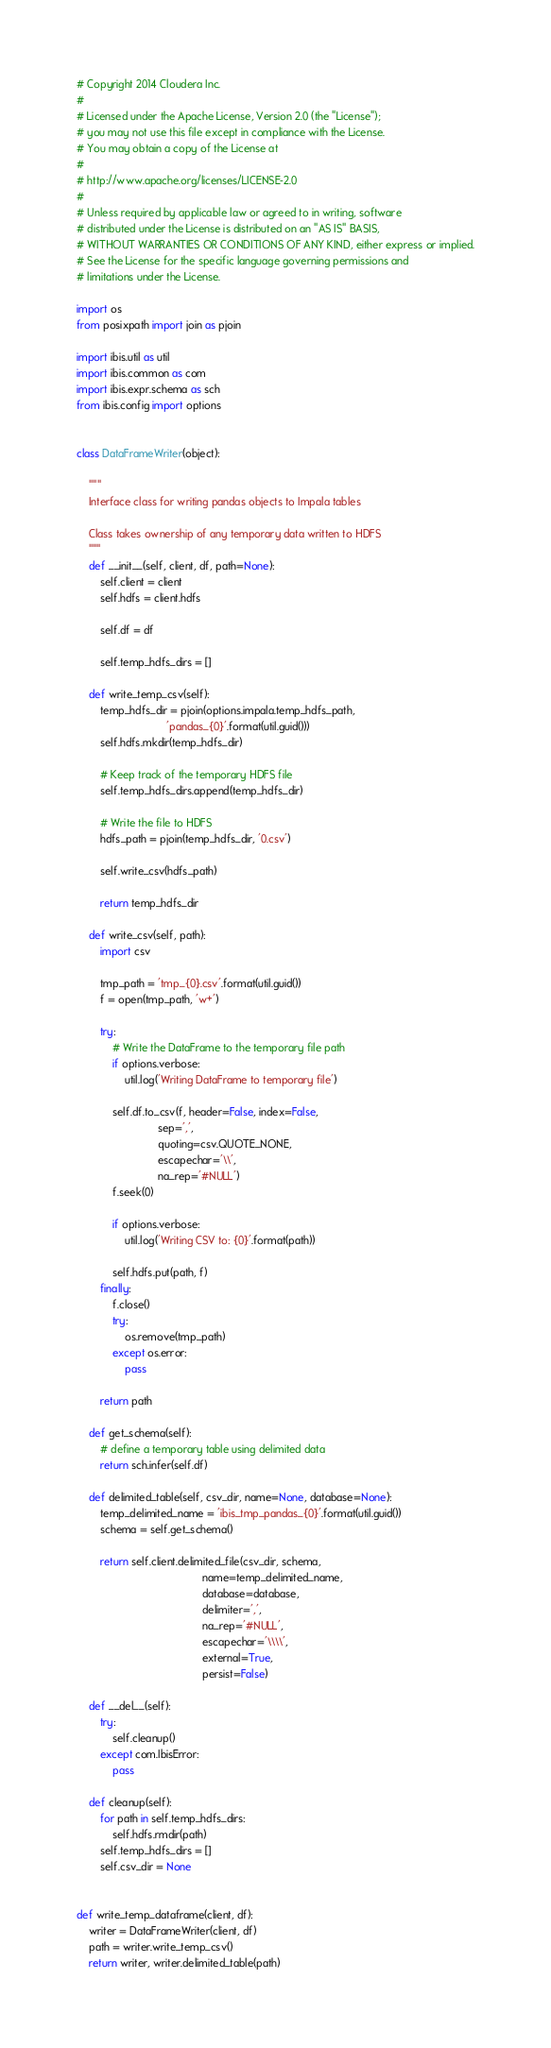Convert code to text. <code><loc_0><loc_0><loc_500><loc_500><_Python_># Copyright 2014 Cloudera Inc.
#
# Licensed under the Apache License, Version 2.0 (the "License");
# you may not use this file except in compliance with the License.
# You may obtain a copy of the License at
#
# http://www.apache.org/licenses/LICENSE-2.0
#
# Unless required by applicable law or agreed to in writing, software
# distributed under the License is distributed on an "AS IS" BASIS,
# WITHOUT WARRANTIES OR CONDITIONS OF ANY KIND, either express or implied.
# See the License for the specific language governing permissions and
# limitations under the License.

import os
from posixpath import join as pjoin

import ibis.util as util
import ibis.common as com
import ibis.expr.schema as sch
from ibis.config import options


class DataFrameWriter(object):

    """
    Interface class for writing pandas objects to Impala tables

    Class takes ownership of any temporary data written to HDFS
    """
    def __init__(self, client, df, path=None):
        self.client = client
        self.hdfs = client.hdfs

        self.df = df

        self.temp_hdfs_dirs = []

    def write_temp_csv(self):
        temp_hdfs_dir = pjoin(options.impala.temp_hdfs_path,
                              'pandas_{0}'.format(util.guid()))
        self.hdfs.mkdir(temp_hdfs_dir)

        # Keep track of the temporary HDFS file
        self.temp_hdfs_dirs.append(temp_hdfs_dir)

        # Write the file to HDFS
        hdfs_path = pjoin(temp_hdfs_dir, '0.csv')

        self.write_csv(hdfs_path)

        return temp_hdfs_dir

    def write_csv(self, path):
        import csv

        tmp_path = 'tmp_{0}.csv'.format(util.guid())
        f = open(tmp_path, 'w+')

        try:
            # Write the DataFrame to the temporary file path
            if options.verbose:
                util.log('Writing DataFrame to temporary file')

            self.df.to_csv(f, header=False, index=False,
                           sep=',',
                           quoting=csv.QUOTE_NONE,
                           escapechar='\\',
                           na_rep='#NULL')
            f.seek(0)

            if options.verbose:
                util.log('Writing CSV to: {0}'.format(path))

            self.hdfs.put(path, f)
        finally:
            f.close()
            try:
                os.remove(tmp_path)
            except os.error:
                pass

        return path

    def get_schema(self):
        # define a temporary table using delimited data
        return sch.infer(self.df)

    def delimited_table(self, csv_dir, name=None, database=None):
        temp_delimited_name = 'ibis_tmp_pandas_{0}'.format(util.guid())
        schema = self.get_schema()

        return self.client.delimited_file(csv_dir, schema,
                                          name=temp_delimited_name,
                                          database=database,
                                          delimiter=',',
                                          na_rep='#NULL',
                                          escapechar='\\\\',
                                          external=True,
                                          persist=False)

    def __del__(self):
        try:
            self.cleanup()
        except com.IbisError:
            pass

    def cleanup(self):
        for path in self.temp_hdfs_dirs:
            self.hdfs.rmdir(path)
        self.temp_hdfs_dirs = []
        self.csv_dir = None


def write_temp_dataframe(client, df):
    writer = DataFrameWriter(client, df)
    path = writer.write_temp_csv()
    return writer, writer.delimited_table(path)
</code> 